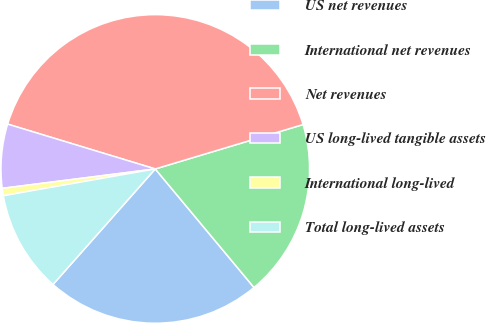<chart> <loc_0><loc_0><loc_500><loc_500><pie_chart><fcel>US net revenues<fcel>International net revenues<fcel>Net revenues<fcel>US long-lived tangible assets<fcel>International long-lived<fcel>Total long-lived assets<nl><fcel>22.58%<fcel>18.59%<fcel>40.66%<fcel>6.7%<fcel>0.77%<fcel>10.69%<nl></chart> 